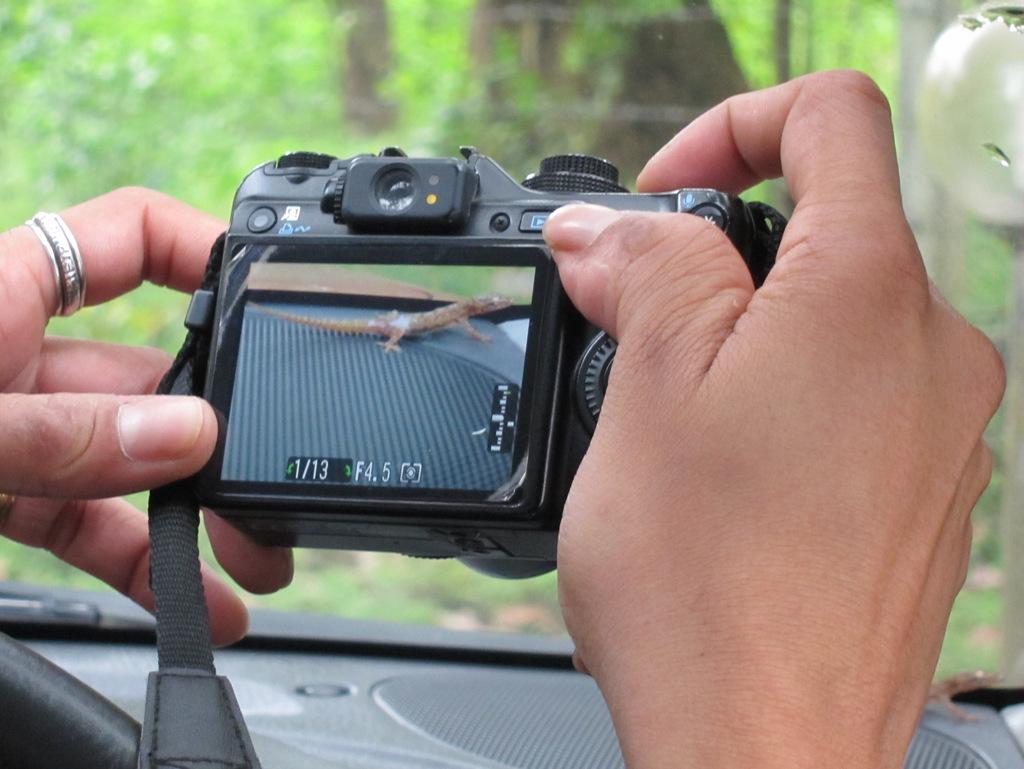How many photos are on the camera?
Keep it short and to the point. 13. What number photo is this one?
Give a very brief answer. 1. 